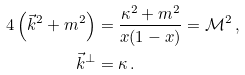<formula> <loc_0><loc_0><loc_500><loc_500>4 \left ( \vec { k } ^ { 2 } + m ^ { 2 } \right ) & = \frac { \kappa ^ { 2 } + m ^ { 2 } } { x ( 1 - x ) } = \mathcal { M } ^ { 2 } \, , \\ \vec { k } ^ { \perp } & = \kappa \, .</formula> 